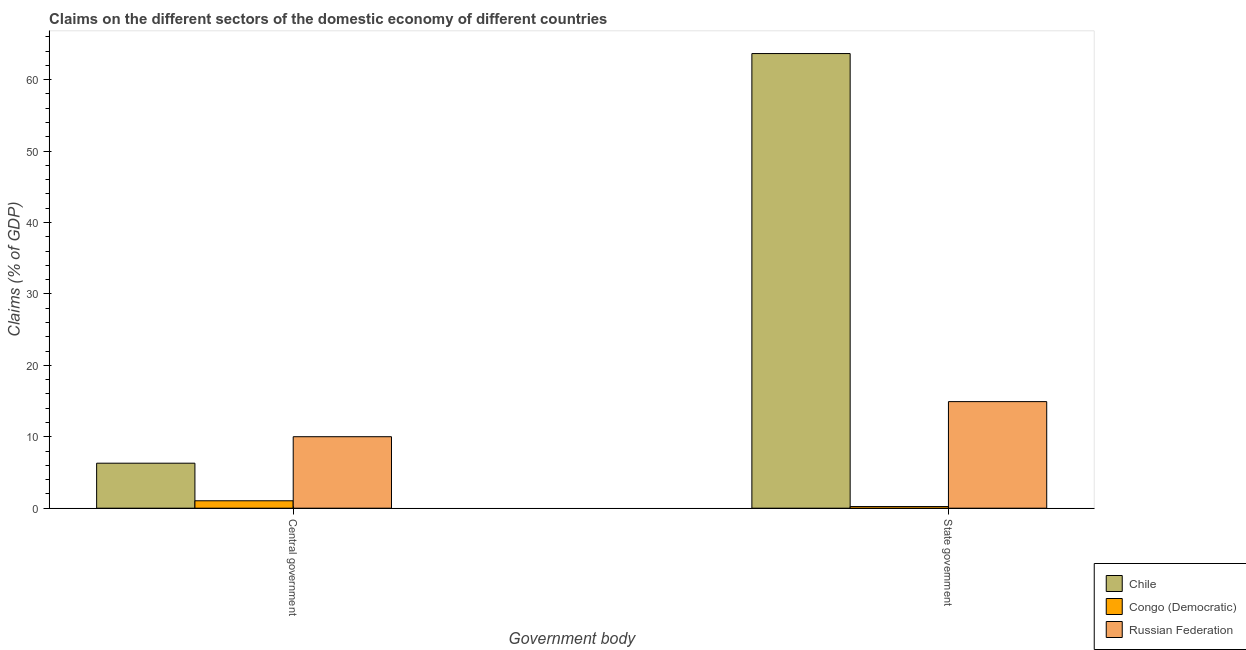How many different coloured bars are there?
Your response must be concise. 3. How many groups of bars are there?
Ensure brevity in your answer.  2. How many bars are there on the 2nd tick from the left?
Provide a short and direct response. 3. How many bars are there on the 2nd tick from the right?
Your answer should be compact. 3. What is the label of the 2nd group of bars from the left?
Make the answer very short. State government. What is the claims on state government in Chile?
Provide a succinct answer. 63.64. Across all countries, what is the maximum claims on state government?
Offer a terse response. 63.64. Across all countries, what is the minimum claims on central government?
Your answer should be very brief. 1.04. In which country was the claims on central government maximum?
Offer a terse response. Russian Federation. In which country was the claims on state government minimum?
Your answer should be very brief. Congo (Democratic). What is the total claims on central government in the graph?
Provide a succinct answer. 17.34. What is the difference between the claims on state government in Russian Federation and that in Chile?
Give a very brief answer. -48.72. What is the difference between the claims on state government in Russian Federation and the claims on central government in Chile?
Offer a terse response. 8.62. What is the average claims on state government per country?
Offer a terse response. 26.26. What is the difference between the claims on state government and claims on central government in Chile?
Your response must be concise. 57.34. What is the ratio of the claims on state government in Chile to that in Russian Federation?
Give a very brief answer. 4.27. Is the claims on state government in Chile less than that in Congo (Democratic)?
Keep it short and to the point. No. In how many countries, is the claims on central government greater than the average claims on central government taken over all countries?
Offer a very short reply. 2. What does the 2nd bar from the left in Central government represents?
Your answer should be very brief. Congo (Democratic). What does the 2nd bar from the right in State government represents?
Provide a short and direct response. Congo (Democratic). How many countries are there in the graph?
Offer a terse response. 3. Are the values on the major ticks of Y-axis written in scientific E-notation?
Your response must be concise. No. Does the graph contain any zero values?
Provide a short and direct response. No. Where does the legend appear in the graph?
Keep it short and to the point. Bottom right. How many legend labels are there?
Keep it short and to the point. 3. How are the legend labels stacked?
Offer a terse response. Vertical. What is the title of the graph?
Provide a short and direct response. Claims on the different sectors of the domestic economy of different countries. What is the label or title of the X-axis?
Your response must be concise. Government body. What is the label or title of the Y-axis?
Give a very brief answer. Claims (% of GDP). What is the Claims (% of GDP) of Chile in Central government?
Offer a very short reply. 6.3. What is the Claims (% of GDP) of Congo (Democratic) in Central government?
Provide a short and direct response. 1.04. What is the Claims (% of GDP) in Russian Federation in Central government?
Offer a terse response. 10.01. What is the Claims (% of GDP) in Chile in State government?
Offer a terse response. 63.64. What is the Claims (% of GDP) of Congo (Democratic) in State government?
Provide a short and direct response. 0.23. What is the Claims (% of GDP) in Russian Federation in State government?
Offer a terse response. 14.92. Across all Government body, what is the maximum Claims (% of GDP) of Chile?
Keep it short and to the point. 63.64. Across all Government body, what is the maximum Claims (% of GDP) of Congo (Democratic)?
Provide a short and direct response. 1.04. Across all Government body, what is the maximum Claims (% of GDP) of Russian Federation?
Provide a short and direct response. 14.92. Across all Government body, what is the minimum Claims (% of GDP) in Chile?
Offer a terse response. 6.3. Across all Government body, what is the minimum Claims (% of GDP) in Congo (Democratic)?
Your answer should be very brief. 0.23. Across all Government body, what is the minimum Claims (% of GDP) in Russian Federation?
Offer a very short reply. 10.01. What is the total Claims (% of GDP) in Chile in the graph?
Offer a very short reply. 69.94. What is the total Claims (% of GDP) of Congo (Democratic) in the graph?
Offer a very short reply. 1.27. What is the total Claims (% of GDP) in Russian Federation in the graph?
Offer a terse response. 24.93. What is the difference between the Claims (% of GDP) of Chile in Central government and that in State government?
Make the answer very short. -57.34. What is the difference between the Claims (% of GDP) in Congo (Democratic) in Central government and that in State government?
Keep it short and to the point. 0.81. What is the difference between the Claims (% of GDP) of Russian Federation in Central government and that in State government?
Your response must be concise. -4.91. What is the difference between the Claims (% of GDP) in Chile in Central government and the Claims (% of GDP) in Congo (Democratic) in State government?
Ensure brevity in your answer.  6.07. What is the difference between the Claims (% of GDP) of Chile in Central government and the Claims (% of GDP) of Russian Federation in State government?
Make the answer very short. -8.62. What is the difference between the Claims (% of GDP) of Congo (Democratic) in Central government and the Claims (% of GDP) of Russian Federation in State government?
Offer a terse response. -13.88. What is the average Claims (% of GDP) of Chile per Government body?
Provide a short and direct response. 34.97. What is the average Claims (% of GDP) in Congo (Democratic) per Government body?
Keep it short and to the point. 0.63. What is the average Claims (% of GDP) of Russian Federation per Government body?
Give a very brief answer. 12.46. What is the difference between the Claims (% of GDP) in Chile and Claims (% of GDP) in Congo (Democratic) in Central government?
Your answer should be compact. 5.26. What is the difference between the Claims (% of GDP) in Chile and Claims (% of GDP) in Russian Federation in Central government?
Ensure brevity in your answer.  -3.71. What is the difference between the Claims (% of GDP) of Congo (Democratic) and Claims (% of GDP) of Russian Federation in Central government?
Offer a very short reply. -8.97. What is the difference between the Claims (% of GDP) of Chile and Claims (% of GDP) of Congo (Democratic) in State government?
Provide a short and direct response. 63.41. What is the difference between the Claims (% of GDP) in Chile and Claims (% of GDP) in Russian Federation in State government?
Make the answer very short. 48.73. What is the difference between the Claims (% of GDP) of Congo (Democratic) and Claims (% of GDP) of Russian Federation in State government?
Your response must be concise. -14.69. What is the ratio of the Claims (% of GDP) in Chile in Central government to that in State government?
Make the answer very short. 0.1. What is the ratio of the Claims (% of GDP) of Congo (Democratic) in Central government to that in State government?
Provide a short and direct response. 4.51. What is the ratio of the Claims (% of GDP) in Russian Federation in Central government to that in State government?
Keep it short and to the point. 0.67. What is the difference between the highest and the second highest Claims (% of GDP) in Chile?
Your response must be concise. 57.34. What is the difference between the highest and the second highest Claims (% of GDP) in Congo (Democratic)?
Give a very brief answer. 0.81. What is the difference between the highest and the second highest Claims (% of GDP) of Russian Federation?
Your response must be concise. 4.91. What is the difference between the highest and the lowest Claims (% of GDP) of Chile?
Provide a short and direct response. 57.34. What is the difference between the highest and the lowest Claims (% of GDP) of Congo (Democratic)?
Offer a very short reply. 0.81. What is the difference between the highest and the lowest Claims (% of GDP) of Russian Federation?
Ensure brevity in your answer.  4.91. 